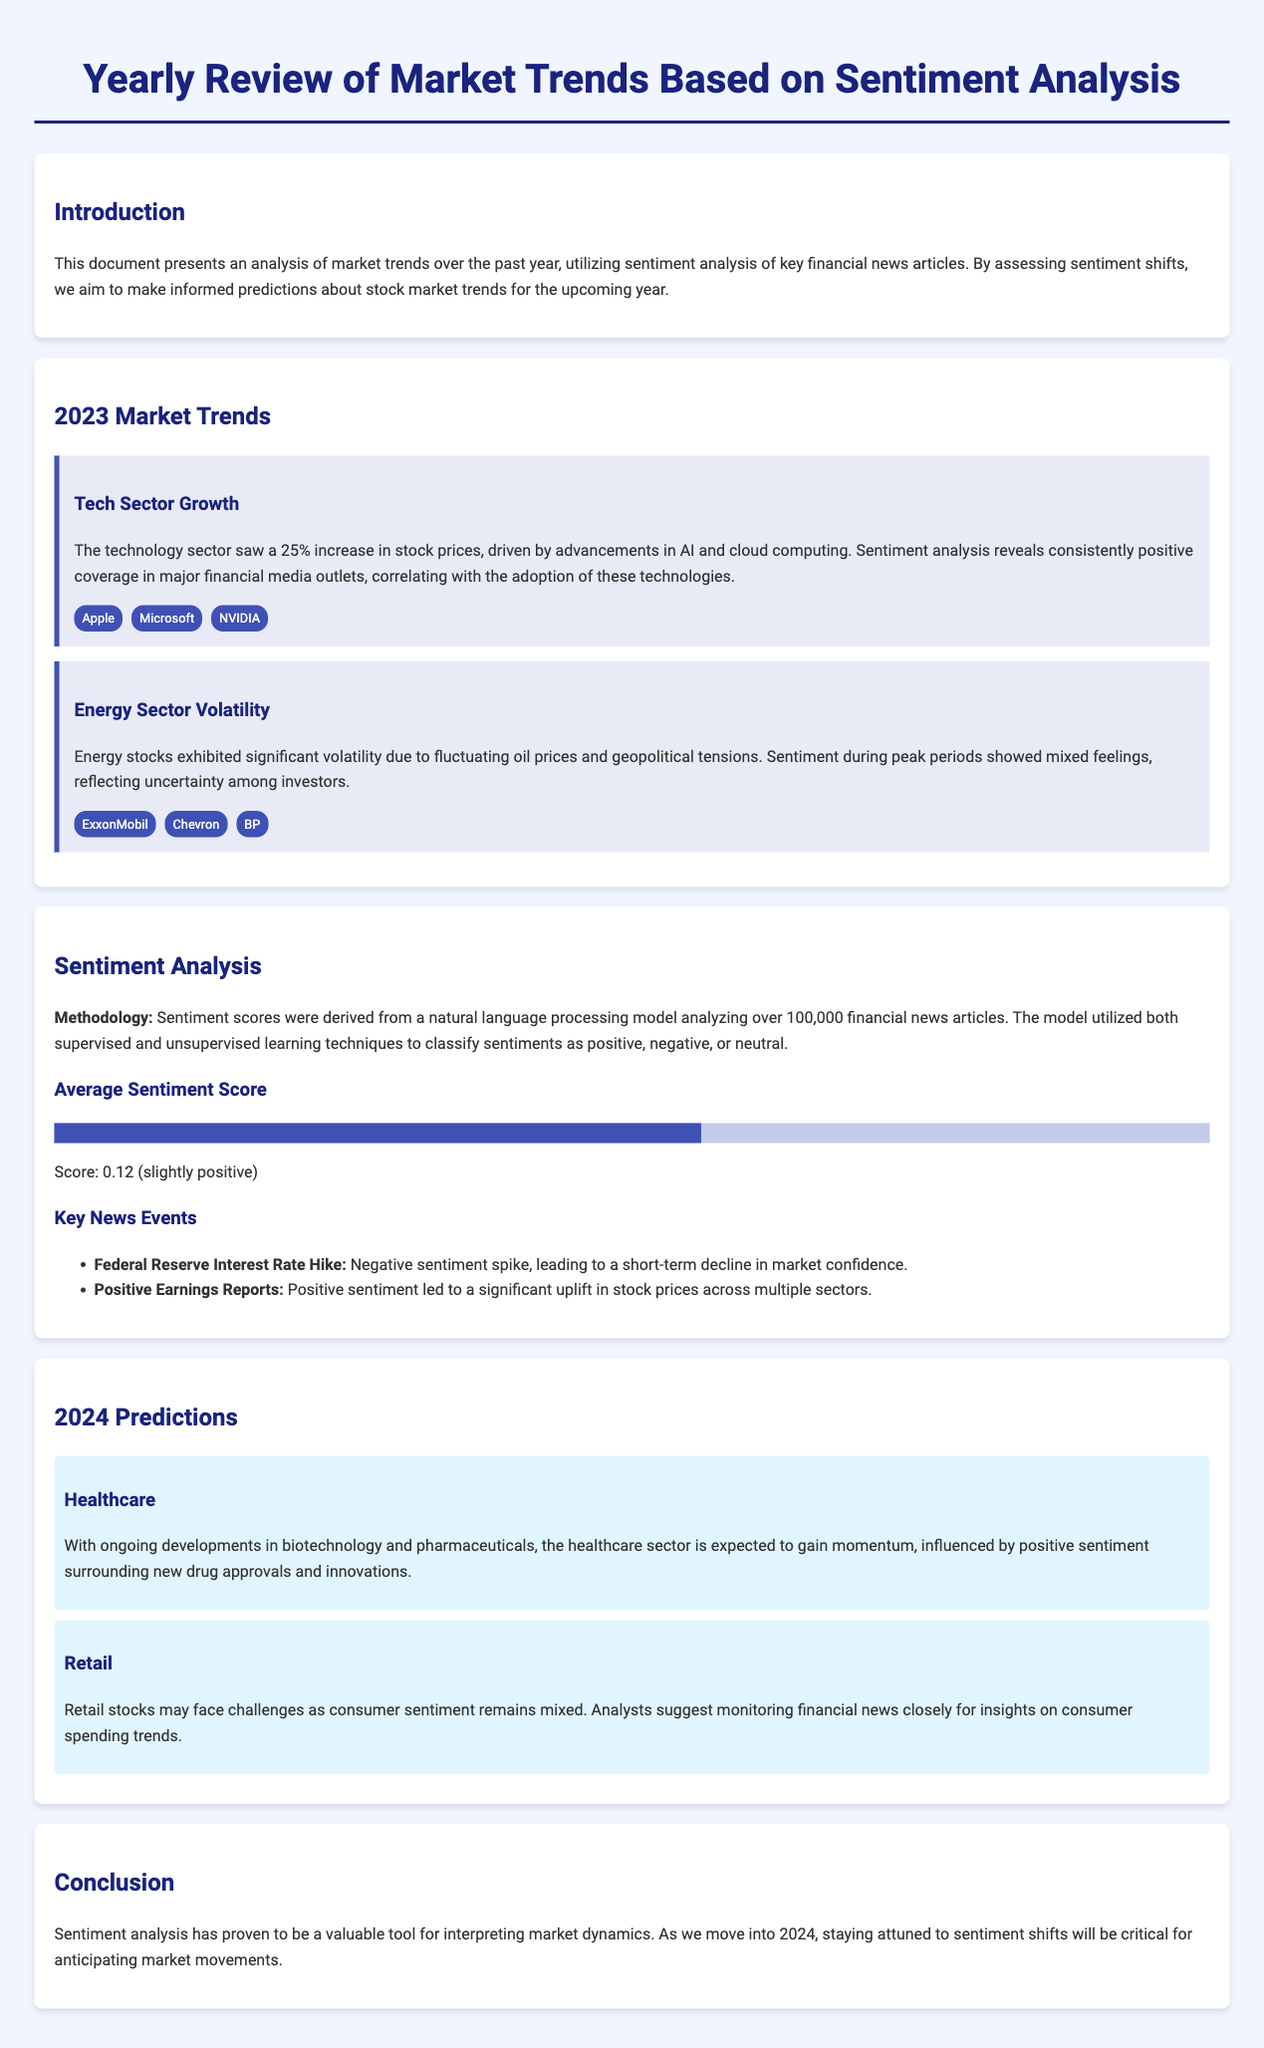what sector experienced a 25% increase in stock prices? The document mentions that the technology sector saw a 25% increase in stock prices driven by advancements in AI and cloud computing.
Answer: technology sector what was the average sentiment score reported? The document states that the average sentiment score was 0.12, indicating a slightly positive sentiment.
Answer: 0.12 which companies are associated with the energy sector volatility? The document lists ExxonMobil, Chevron, and BP in connection with the volatility seen in energy stocks.
Answer: ExxonMobil, Chevron, BP what type of sentiment spike did the Federal Reserve interest rate hike cause? The Federal Reserve interest rate hike led to a negative sentiment spike, as mentioned in the key news events section.
Answer: negative which sector is predicted to gain momentum due to positive sentiment surrounding new drug approvals? In the predictions section, it is stated that the healthcare sector is expected to gain momentum influenced by positive sentiment.
Answer: healthcare what year is the focus of the predictions made in the document? The document explicitly discusses predictions for the upcoming year, which is 2024.
Answer: 2024 how were sentiment scores derived? The document explains that sentiment scores were derived from a natural language processing model analyzing over 100,000 financial news articles.
Answer: natural language processing model what sentiments surround retail stocks according to the document? The document indicates that retail stocks may face challenges as consumer sentiment remains mixed.
Answer: mixed how many financial news articles were analyzed in the sentiment analysis? The document states that over 100,000 financial news articles were analyzed for the sentiment analysis.
Answer: 100,000 